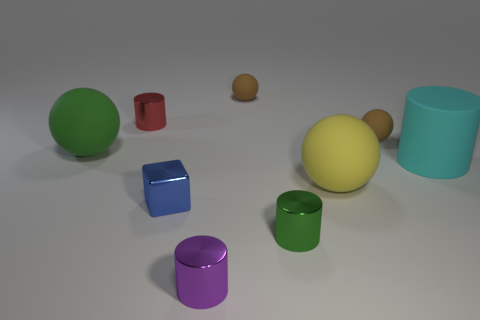Is the number of big cyan rubber cylinders less than the number of red shiny cubes?
Keep it short and to the point. No. Are there any other things that are the same color as the small block?
Offer a very short reply. No. There is a rubber thing on the left side of the blue object; what size is it?
Provide a succinct answer. Large. Are there more big cyan cylinders than big cyan metal objects?
Keep it short and to the point. Yes. What is the green cylinder made of?
Offer a terse response. Metal. What number of other things are there of the same material as the large cyan cylinder
Ensure brevity in your answer.  4. What number of small gray matte balls are there?
Your response must be concise. 0. What material is the tiny green object that is the same shape as the cyan object?
Your answer should be very brief. Metal. Are the tiny cylinder that is right of the small purple cylinder and the large yellow sphere made of the same material?
Your answer should be very brief. No. Are there more shiny objects behind the small purple metallic object than big rubber spheres that are right of the big yellow rubber sphere?
Give a very brief answer. Yes. 